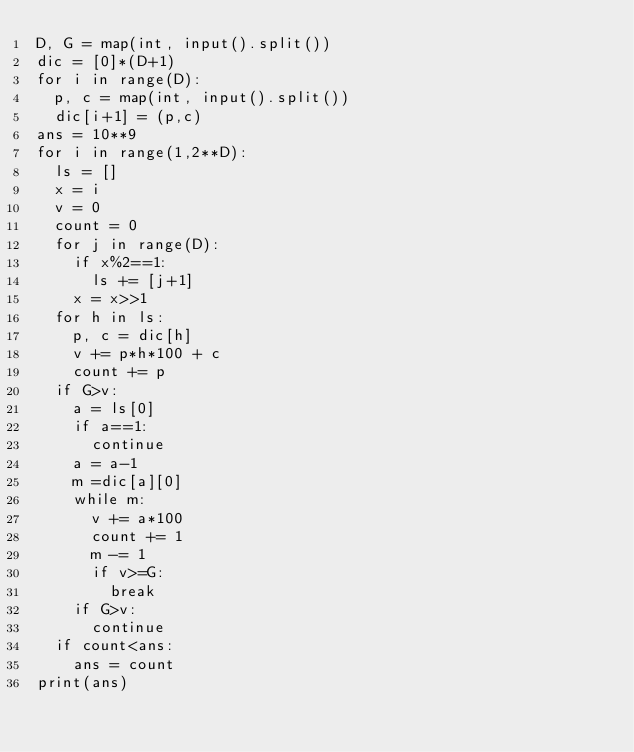<code> <loc_0><loc_0><loc_500><loc_500><_Python_>D, G = map(int, input().split())
dic = [0]*(D+1)
for i in range(D):
  p, c = map(int, input().split())
  dic[i+1] = (p,c)
ans = 10**9
for i in range(1,2**D):
  ls = []
  x = i
  v = 0
  count = 0
  for j in range(D):
    if x%2==1:
      ls += [j+1]
    x = x>>1
  for h in ls:
    p, c = dic[h]
    v += p*h*100 + c
    count += p
  if G>v:
    a = ls[0]
    if a==1:
      continue
    a = a-1
    m =dic[a][0]
    while m:
      v += a*100
      count += 1
      m -= 1
      if v>=G:
        break
    if G>v:
      continue
  if count<ans:
    ans = count
print(ans)</code> 